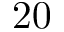Convert formula to latex. <formula><loc_0><loc_0><loc_500><loc_500>\ 2 0</formula> 